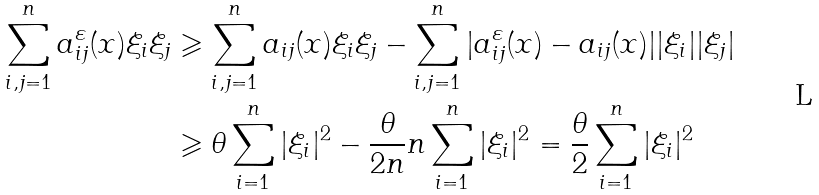<formula> <loc_0><loc_0><loc_500><loc_500>\sum _ { i , j = 1 } ^ { n } a _ { i j } ^ { \varepsilon } ( x ) \xi _ { i } \xi _ { j } & \geqslant \sum _ { i , j = 1 } ^ { n } a _ { i j } ( x ) \xi _ { i } \xi _ { j } - \sum _ { i , j = 1 } ^ { n } | a _ { i j } ^ { \varepsilon } ( x ) - a _ { i j } ( x ) | | \xi _ { i } | | \xi _ { j } | \\ & \geqslant \theta \sum _ { i = 1 } ^ { n } | \xi _ { i } | ^ { 2 } - \frac { \theta } { 2 n } n \sum _ { i = 1 } ^ { n } | \xi _ { i } | ^ { 2 } = \frac { \theta } { 2 } \sum _ { i = 1 } ^ { n } | \xi _ { i } | ^ { 2 }</formula> 